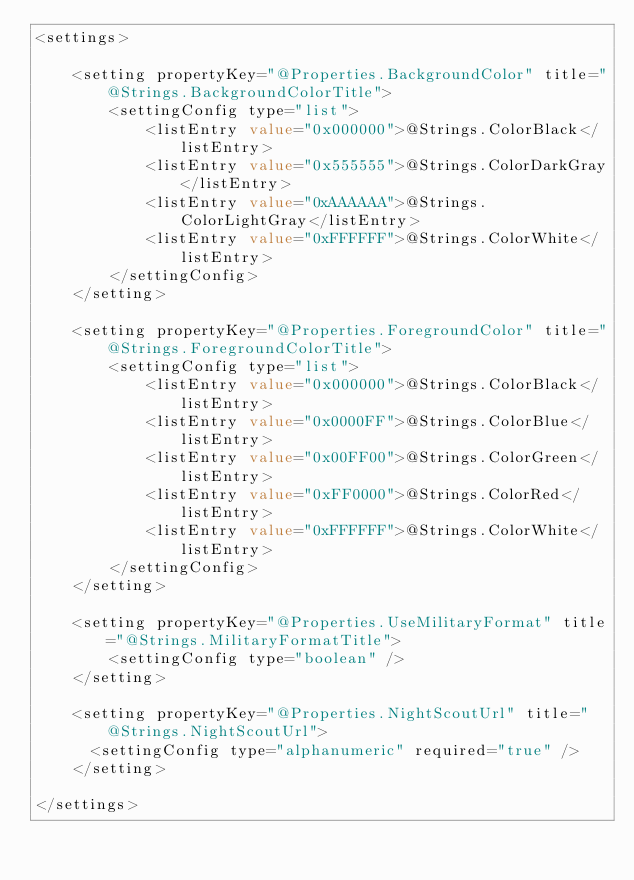Convert code to text. <code><loc_0><loc_0><loc_500><loc_500><_XML_><settings>

    <setting propertyKey="@Properties.BackgroundColor" title="@Strings.BackgroundColorTitle">
        <settingConfig type="list">
            <listEntry value="0x000000">@Strings.ColorBlack</listEntry>
            <listEntry value="0x555555">@Strings.ColorDarkGray</listEntry>
            <listEntry value="0xAAAAAA">@Strings.ColorLightGray</listEntry>
            <listEntry value="0xFFFFFF">@Strings.ColorWhite</listEntry>
        </settingConfig>
    </setting>

    <setting propertyKey="@Properties.ForegroundColor" title="@Strings.ForegroundColorTitle">
        <settingConfig type="list">
            <listEntry value="0x000000">@Strings.ColorBlack</listEntry>
            <listEntry value="0x0000FF">@Strings.ColorBlue</listEntry>
            <listEntry value="0x00FF00">@Strings.ColorGreen</listEntry>
            <listEntry value="0xFF0000">@Strings.ColorRed</listEntry>
            <listEntry value="0xFFFFFF">@Strings.ColorWhite</listEntry>
        </settingConfig>
    </setting>

    <setting propertyKey="@Properties.UseMilitaryFormat" title="@Strings.MilitaryFormatTitle">
        <settingConfig type="boolean" />
    </setting>
    
    <setting propertyKey="@Properties.NightScoutUrl" title="@Strings.NightScoutUrl">
    	<settingConfig type="alphanumeric" required="true" />
    </setting>

</settings>
</code> 